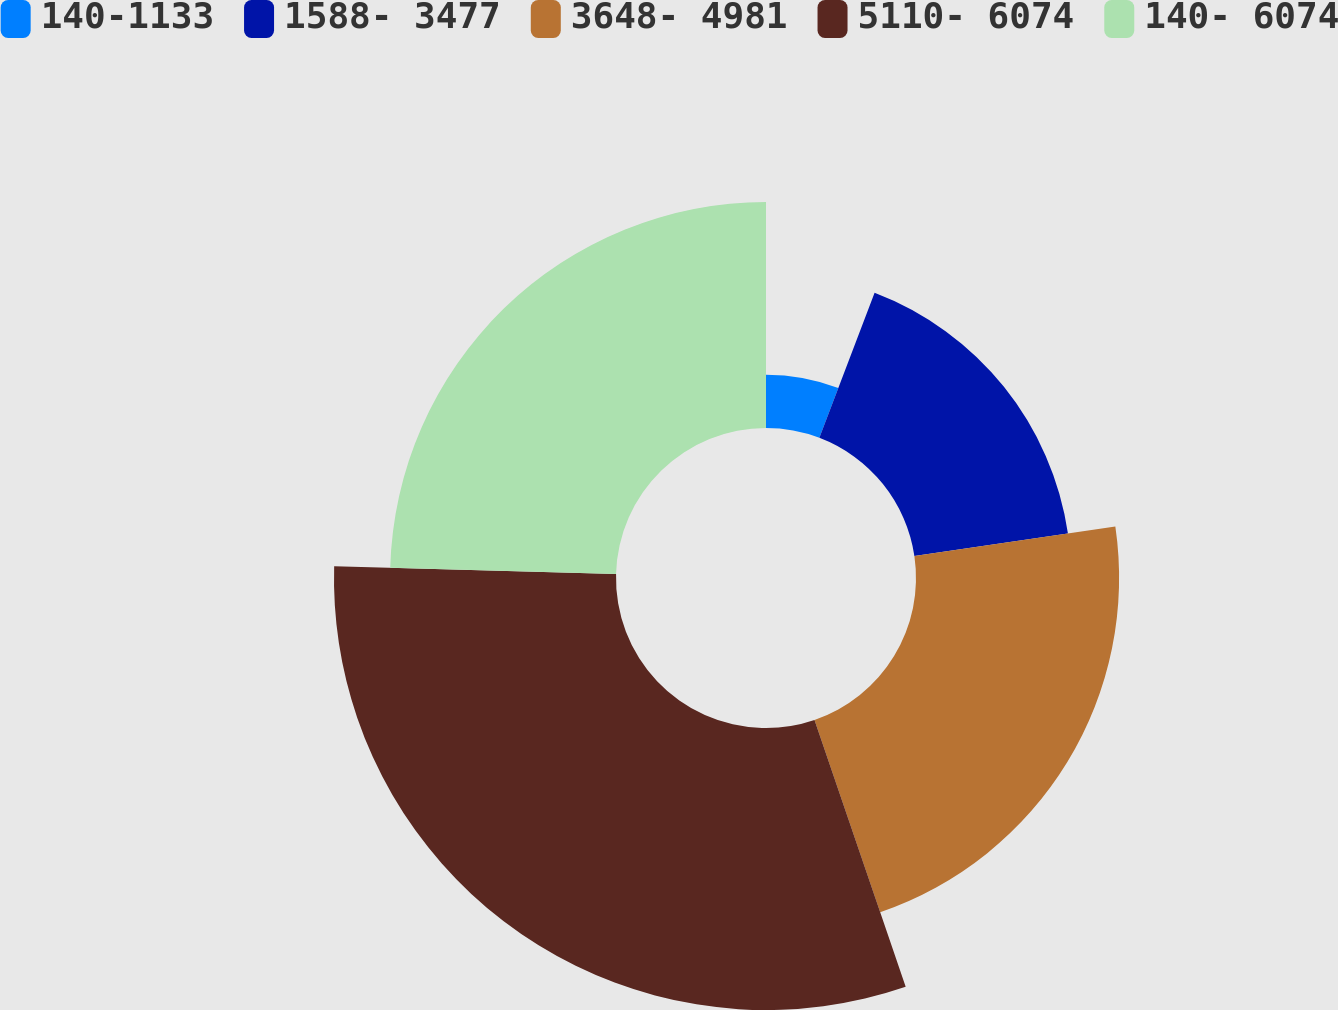Convert chart to OTSL. <chart><loc_0><loc_0><loc_500><loc_500><pie_chart><fcel>140-1133<fcel>1588- 3477<fcel>3648- 4981<fcel>5110- 6074<fcel>140- 6074<nl><fcel>5.79%<fcel>16.88%<fcel>22.09%<fcel>30.67%<fcel>24.57%<nl></chart> 